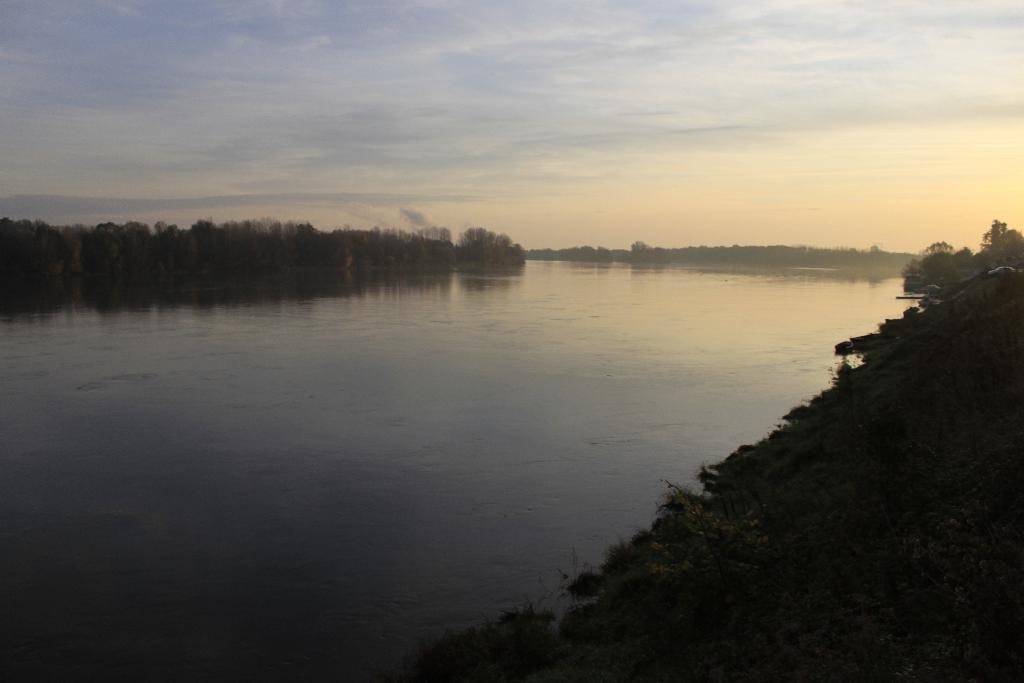What is visible in the image? Water is visible in the image. What type of vegetation can be seen in the image? There are trees in the image. What can be seen in the background of the image? There are clouds visible in the background of the image. Can you tell me how many bulbs are hanging from the trees in the image? There are no bulbs present in the image; it features water, trees, and clouds. How does the town look in the image? There is no town present in the image. 